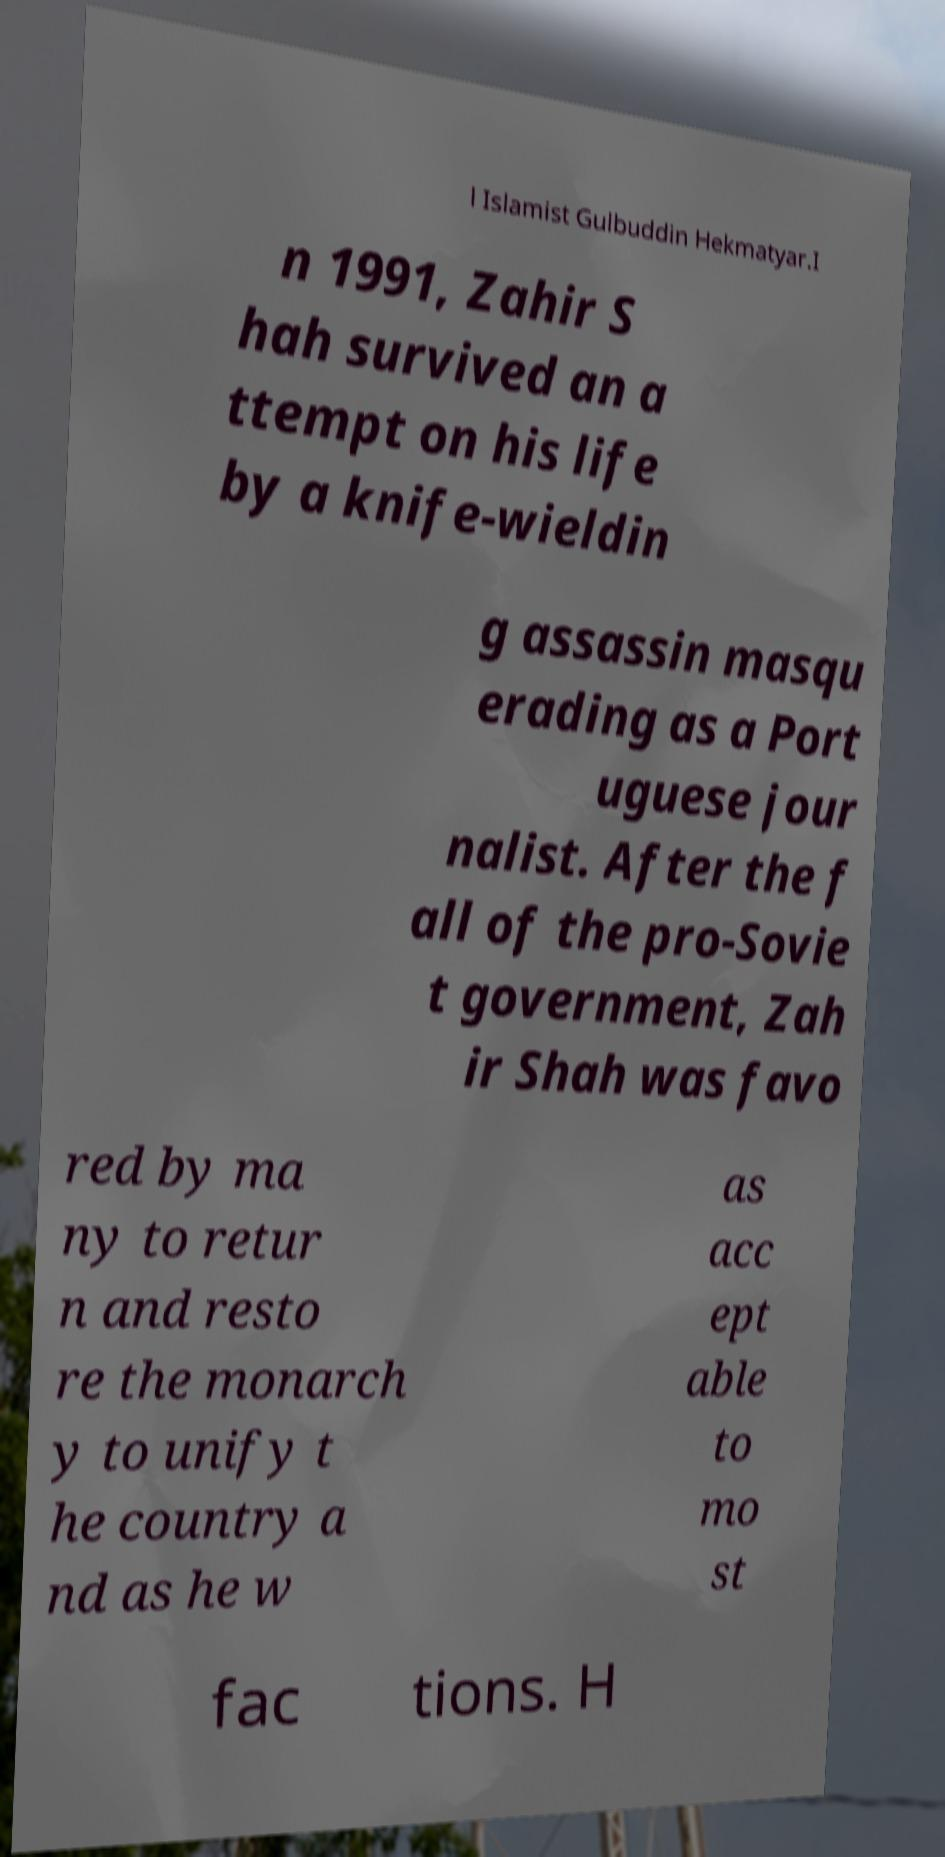Can you accurately transcribe the text from the provided image for me? l Islamist Gulbuddin Hekmatyar.I n 1991, Zahir S hah survived an a ttempt on his life by a knife-wieldin g assassin masqu erading as a Port uguese jour nalist. After the f all of the pro-Sovie t government, Zah ir Shah was favo red by ma ny to retur n and resto re the monarch y to unify t he country a nd as he w as acc ept able to mo st fac tions. H 